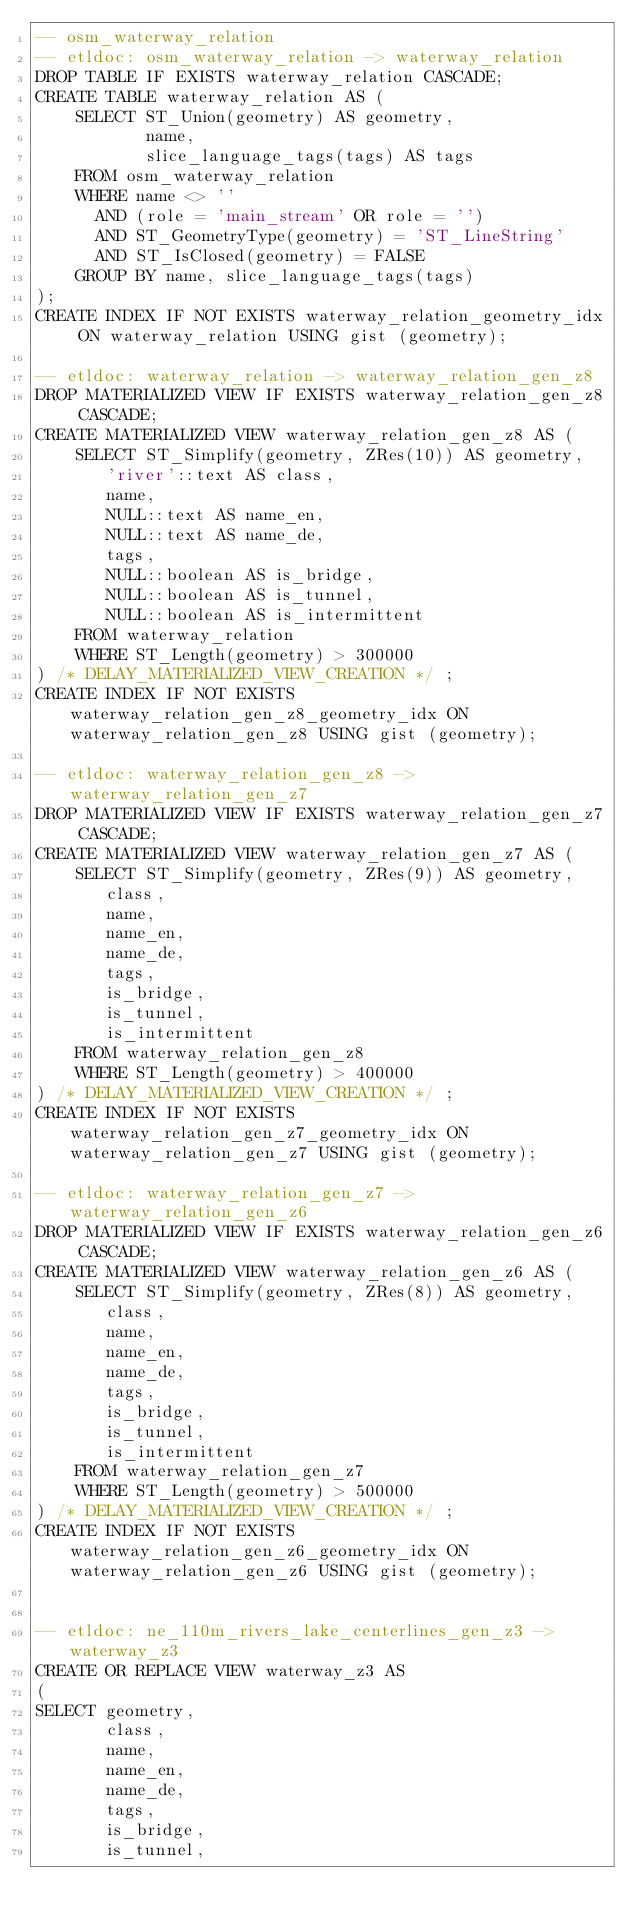<code> <loc_0><loc_0><loc_500><loc_500><_SQL_>-- osm_waterway_relation
-- etldoc: osm_waterway_relation -> waterway_relation
DROP TABLE IF EXISTS waterway_relation CASCADE;
CREATE TABLE waterway_relation AS (
    SELECT ST_Union(geometry) AS geometry,
           name,
           slice_language_tags(tags) AS tags
    FROM osm_waterway_relation
    WHERE name <> ''
      AND (role = 'main_stream' OR role = '')
      AND ST_GeometryType(geometry) = 'ST_LineString'
      AND ST_IsClosed(geometry) = FALSE
    GROUP BY name, slice_language_tags(tags)
);
CREATE INDEX IF NOT EXISTS waterway_relation_geometry_idx ON waterway_relation USING gist (geometry);

-- etldoc: waterway_relation -> waterway_relation_gen_z8
DROP MATERIALIZED VIEW IF EXISTS waterway_relation_gen_z8 CASCADE;
CREATE MATERIALIZED VIEW waterway_relation_gen_z8 AS (
    SELECT ST_Simplify(geometry, ZRes(10)) AS geometry,
       'river'::text AS class,
       name,
       NULL::text AS name_en,
       NULL::text AS name_de,
       tags,
       NULL::boolean AS is_bridge,
       NULL::boolean AS is_tunnel,
       NULL::boolean AS is_intermittent
    FROM waterway_relation
    WHERE ST_Length(geometry) > 300000
) /* DELAY_MATERIALIZED_VIEW_CREATION */ ;
CREATE INDEX IF NOT EXISTS waterway_relation_gen_z8_geometry_idx ON waterway_relation_gen_z8 USING gist (geometry);

-- etldoc: waterway_relation_gen_z8 -> waterway_relation_gen_z7
DROP MATERIALIZED VIEW IF EXISTS waterway_relation_gen_z7 CASCADE;
CREATE MATERIALIZED VIEW waterway_relation_gen_z7 AS (
    SELECT ST_Simplify(geometry, ZRes(9)) AS geometry,
       class,
       name,
       name_en,
       name_de,
       tags,
       is_bridge,
       is_tunnel,
       is_intermittent
    FROM waterway_relation_gen_z8
    WHERE ST_Length(geometry) > 400000
) /* DELAY_MATERIALIZED_VIEW_CREATION */ ;
CREATE INDEX IF NOT EXISTS waterway_relation_gen_z7_geometry_idx ON waterway_relation_gen_z7 USING gist (geometry);

-- etldoc: waterway_relation_gen_z7 -> waterway_relation_gen_z6
DROP MATERIALIZED VIEW IF EXISTS waterway_relation_gen_z6 CASCADE;
CREATE MATERIALIZED VIEW waterway_relation_gen_z6 AS (
    SELECT ST_Simplify(geometry, ZRes(8)) AS geometry,
       class,
       name,
       name_en,
       name_de,
       tags,
       is_bridge,
       is_tunnel,
       is_intermittent
    FROM waterway_relation_gen_z7
    WHERE ST_Length(geometry) > 500000
) /* DELAY_MATERIALIZED_VIEW_CREATION */ ;
CREATE INDEX IF NOT EXISTS waterway_relation_gen_z6_geometry_idx ON waterway_relation_gen_z6 USING gist (geometry);


-- etldoc: ne_110m_rivers_lake_centerlines_gen_z3 ->  waterway_z3
CREATE OR REPLACE VIEW waterway_z3 AS
(
SELECT geometry,
       class,
       name,
       name_en,
       name_de,
       tags,
       is_bridge,
       is_tunnel,</code> 